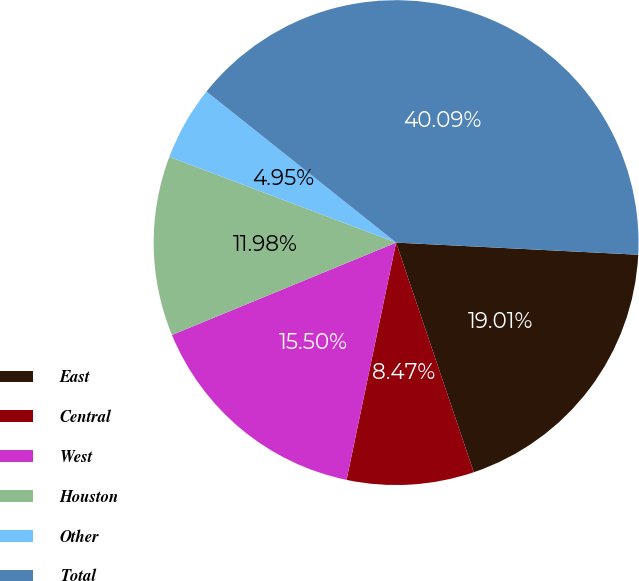<chart> <loc_0><loc_0><loc_500><loc_500><pie_chart><fcel>East<fcel>Central<fcel>West<fcel>Houston<fcel>Other<fcel>Total<nl><fcel>19.01%<fcel>8.47%<fcel>15.5%<fcel>11.98%<fcel>4.95%<fcel>40.09%<nl></chart> 